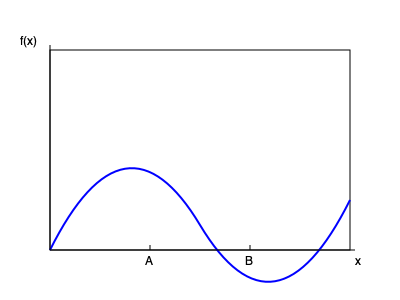Given the population distribution graph above, where the x-axis represents a continuous variable and the y-axis represents the population density, design an optimal stratified sampling strategy. Specifically, determine the number of strata and their boundaries to minimize the overall sampling variance. Assume you can choose up to 3 strata, and points A and B on the x-axis represent potential stratum boundaries. How would you allocate a sample size of $n=300$ across the strata to achieve optimal allocation? To design an optimal stratified sampling strategy, we'll follow these steps:

1. Determine the number of strata:
   Given the shape of the distribution, which shows two distinct regions of high density separated by a region of lower density, we should use 3 strata to capture this variation effectively.

2. Identify stratum boundaries:
   We'll use points A and B as our stratum boundaries, dividing the population into three strata: [0, A], (A, B], and (B, 1].

3. Estimate the proportion of the population in each stratum ($W_h$):
   We can approximate this by estimating the area under the curve for each stratum. Let's assume:
   $W_1 = 0.3$, $W_2 = 0.5$, $W_3 = 0.2$

4. Estimate the standard deviation within each stratum ($S_h$):
   Based on the curve's shape, let's estimate:
   $S_1 = 0.15$, $S_2 = 0.10$, $S_3 = 0.20$

5. Calculate the optimal allocation using Neyman allocation:
   The formula for optimal allocation is:
   $$n_h = n \frac{W_h S_h}{\sum_{i=1}^{L} W_i S_i}$$

   Calculating the denominator:
   $\sum_{i=1}^{L} W_i S_i = (0.3 * 0.15) + (0.5 * 0.10) + (0.2 * 0.20) = 0.045 + 0.050 + 0.040 = 0.135$

   Now, for each stratum:
   $n_1 = 300 * \frac{0.3 * 0.15}{0.135} = 100$
   $n_2 = 300 * \frac{0.5 * 0.10}{0.135} = 111$
   $n_3 = 300 * \frac{0.2 * 0.20}{0.135} = 89$

Therefore, the optimal allocation for a sample size of 300 across the three strata is approximately 100, 111, and 89 for strata 1, 2, and 3, respectively.
Answer: Use 3 strata with boundaries at A and B. Allocate approximately 100, 111, and 89 samples to strata 1, 2, and 3, respectively. 